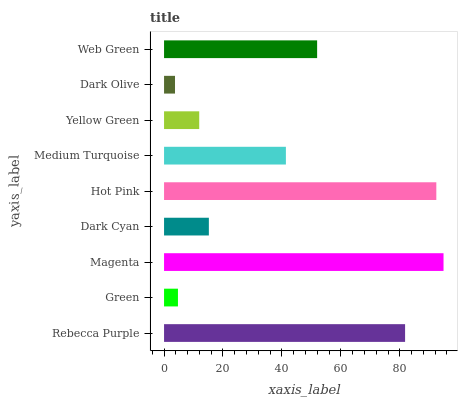Is Dark Olive the minimum?
Answer yes or no. Yes. Is Magenta the maximum?
Answer yes or no. Yes. Is Green the minimum?
Answer yes or no. No. Is Green the maximum?
Answer yes or no. No. Is Rebecca Purple greater than Green?
Answer yes or no. Yes. Is Green less than Rebecca Purple?
Answer yes or no. Yes. Is Green greater than Rebecca Purple?
Answer yes or no. No. Is Rebecca Purple less than Green?
Answer yes or no. No. Is Medium Turquoise the high median?
Answer yes or no. Yes. Is Medium Turquoise the low median?
Answer yes or no. Yes. Is Dark Olive the high median?
Answer yes or no. No. Is Green the low median?
Answer yes or no. No. 